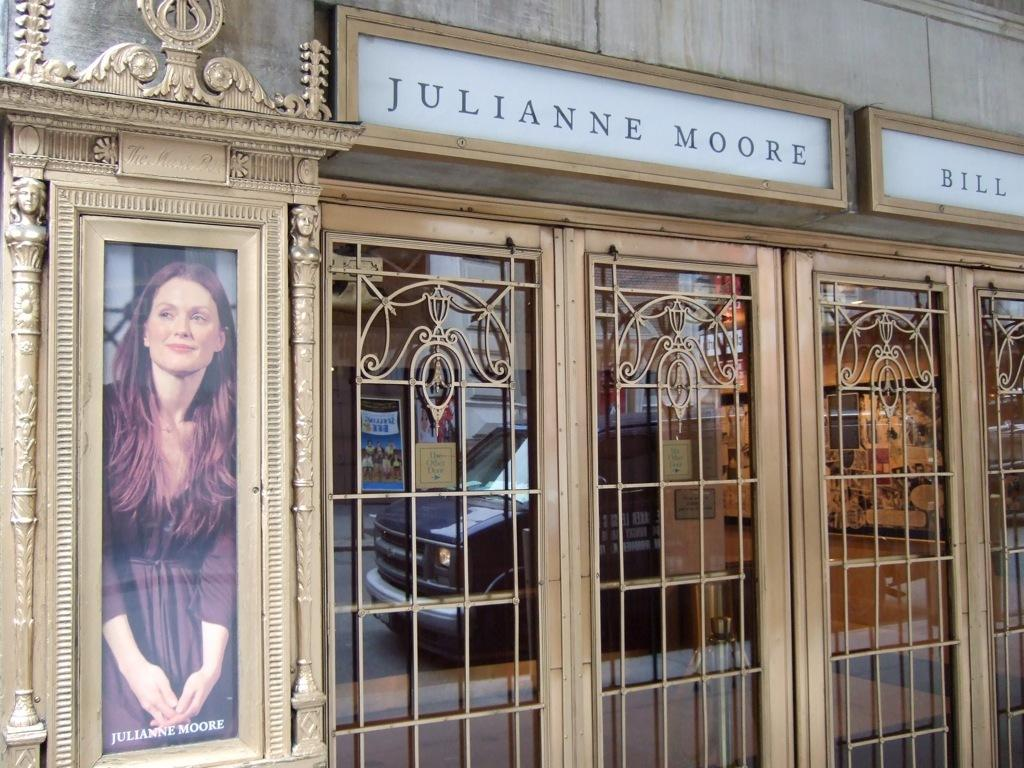<image>
Present a compact description of the photo's key features. Double doors to a building with the name julianne moore with a picture of her on the side. 